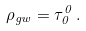<formula> <loc_0><loc_0><loc_500><loc_500>\rho _ { g w } = \tau _ { 0 } ^ { 0 } \, .</formula> 